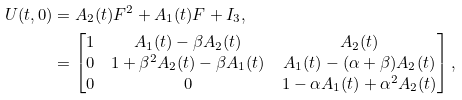<formula> <loc_0><loc_0><loc_500><loc_500>U ( t , 0 ) & = A _ { 2 } ( t ) F ^ { 2 } + A _ { 1 } ( t ) F + I _ { 3 } , \\ & = \begin{bmatrix} 1 & A _ { 1 } ( t ) - \beta A _ { 2 } ( t ) & A _ { 2 } ( t ) \\ 0 & 1 + \beta ^ { 2 } A _ { 2 } ( t ) - \beta A _ { 1 } ( t ) & A _ { 1 } ( t ) - ( \alpha + \beta ) A _ { 2 } ( t ) \\ 0 & 0 & 1 - \alpha A _ { 1 } ( t ) + \alpha ^ { 2 } A _ { 2 } ( t ) \end{bmatrix} ,</formula> 